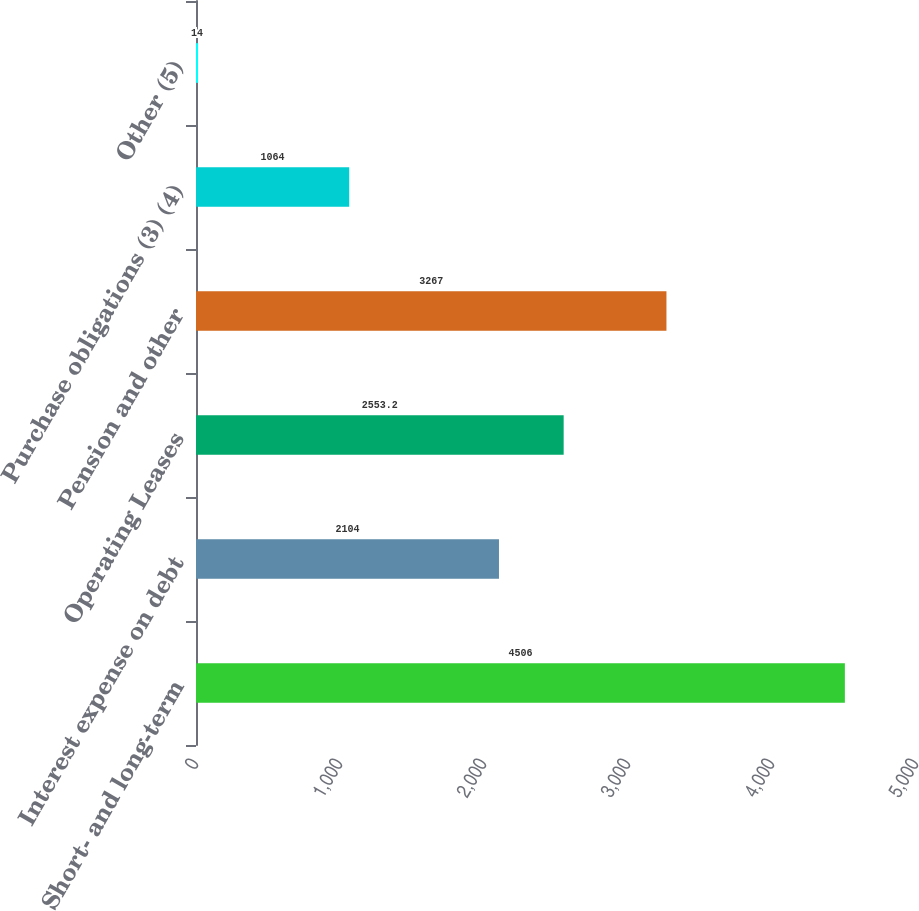Convert chart to OTSL. <chart><loc_0><loc_0><loc_500><loc_500><bar_chart><fcel>Short- and long-term<fcel>Interest expense on debt<fcel>Operating Leases<fcel>Pension and other<fcel>Purchase obligations (3) (4)<fcel>Other (5)<nl><fcel>4506<fcel>2104<fcel>2553.2<fcel>3267<fcel>1064<fcel>14<nl></chart> 